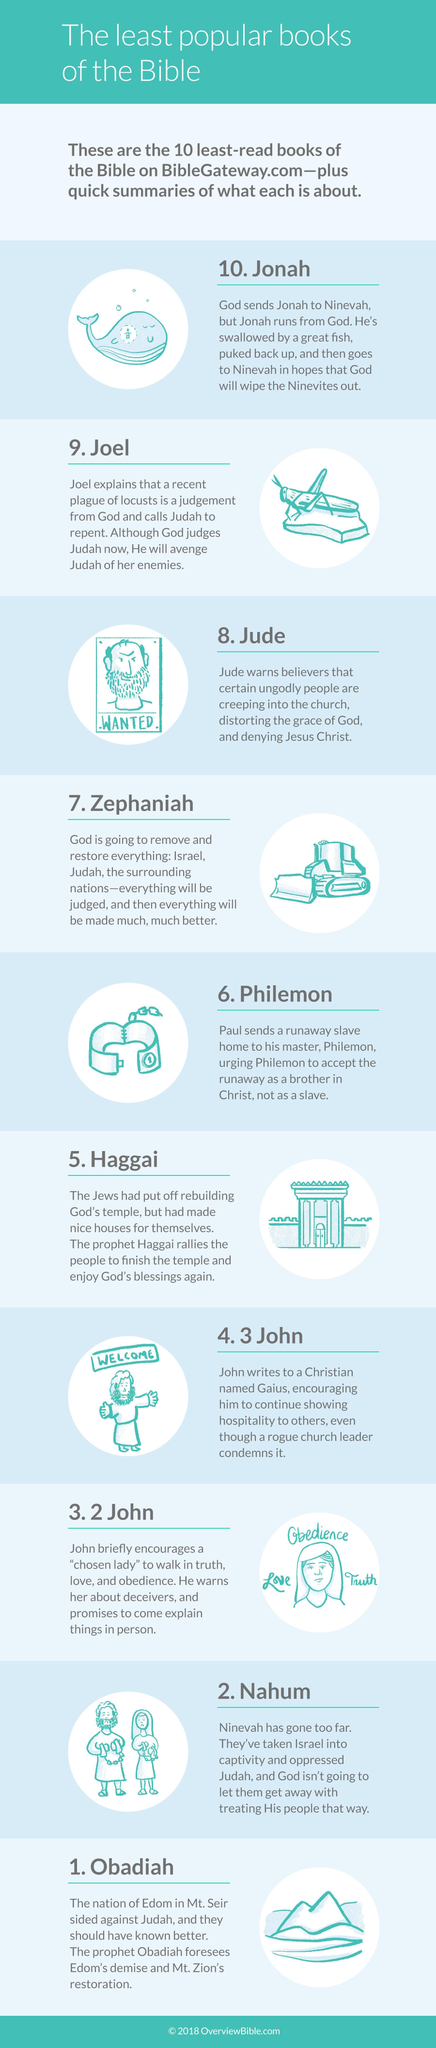How many images are in this infographic?
Answer the question with a short phrase. 10 